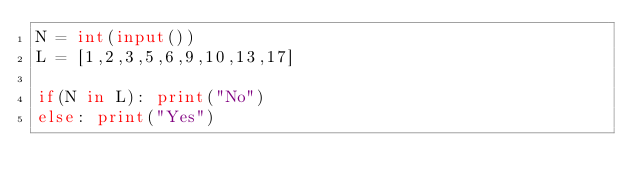<code> <loc_0><loc_0><loc_500><loc_500><_Python_>N = int(input())
L = [1,2,3,5,6,9,10,13,17]

if(N in L):	print("No")
else:	print("Yes")</code> 